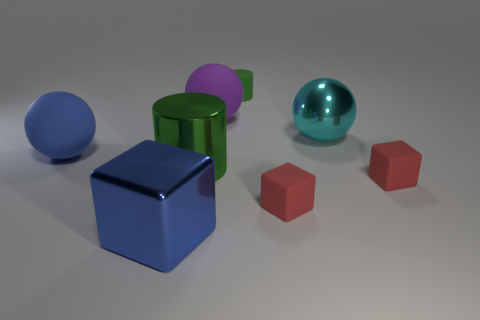There is a big blue object that is the same shape as the large cyan object; what material is it?
Your answer should be compact. Rubber. The tiny matte cube that is left of the tiny red rubber thing on the right side of the cyan metal object is what color?
Your answer should be very brief. Red. What number of large green cylinders have the same material as the blue cube?
Ensure brevity in your answer.  1. What number of metallic objects are either purple cubes or blue blocks?
Your answer should be compact. 1. There is a purple sphere that is the same size as the blue block; what material is it?
Provide a short and direct response. Rubber. Are there any big blue things made of the same material as the big cyan thing?
Make the answer very short. Yes. What shape is the red thing that is to the left of the red cube behind the red block that is to the left of the metal ball?
Your answer should be compact. Cube. Is the size of the purple thing the same as the green object that is left of the purple matte sphere?
Keep it short and to the point. Yes. There is a thing that is both on the left side of the small green matte thing and in front of the large green metallic cylinder; what is its shape?
Give a very brief answer. Cube. How many big objects are blocks or cylinders?
Your answer should be compact. 2. 